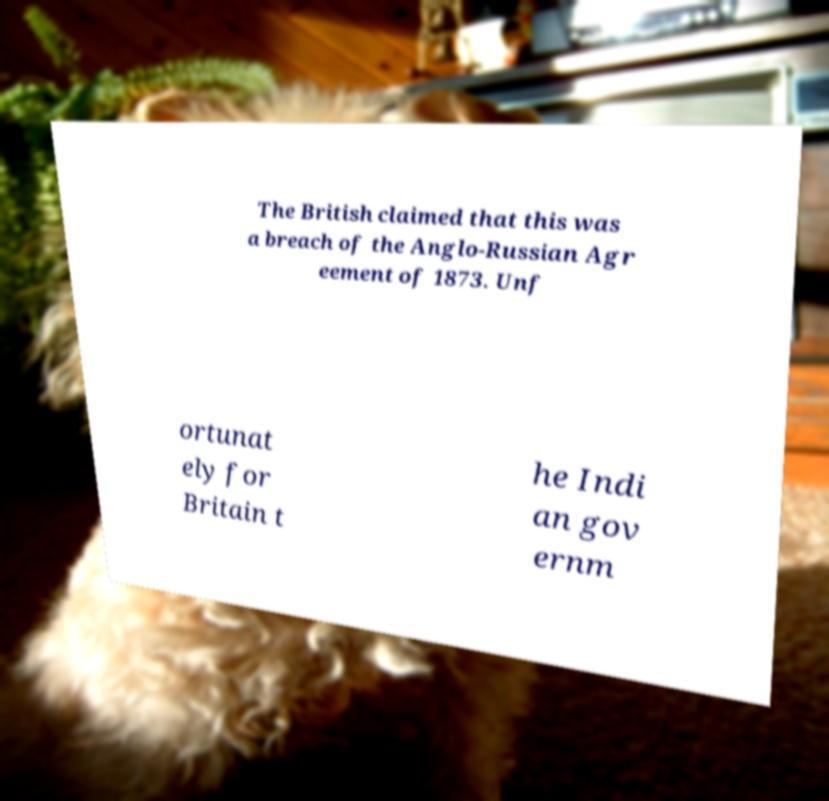Could you extract and type out the text from this image? The British claimed that this was a breach of the Anglo-Russian Agr eement of 1873. Unf ortunat ely for Britain t he Indi an gov ernm 